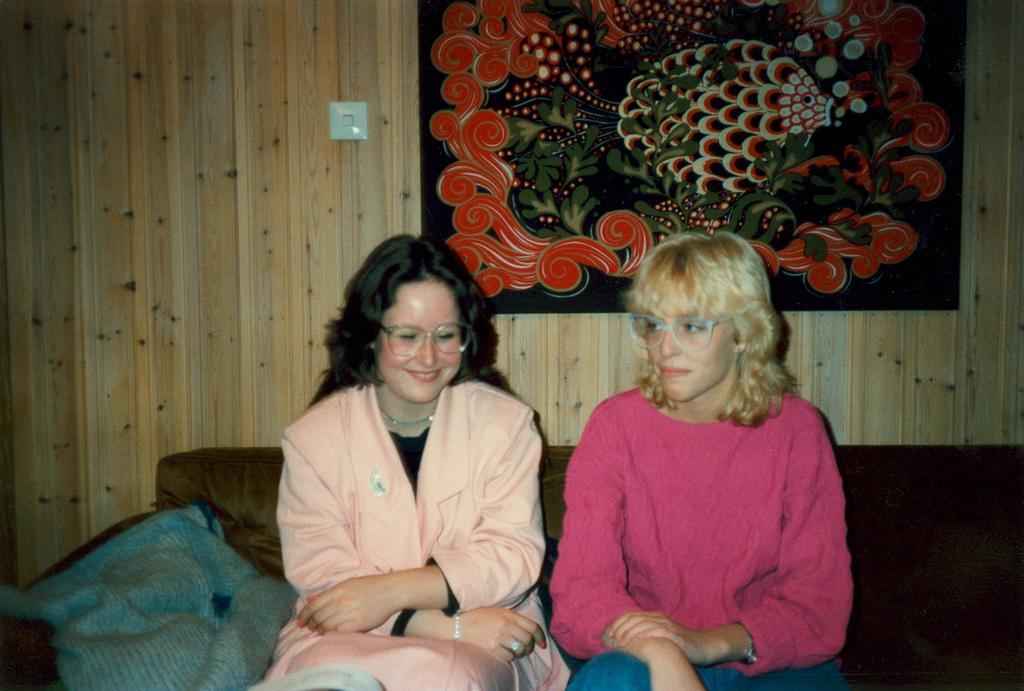Please provide a concise description of this image. In this picture we can see two women wore spectacles and sitting on a sofa and smiling and beside them we can see a cloth and in the background we can see a frame on the wall. 